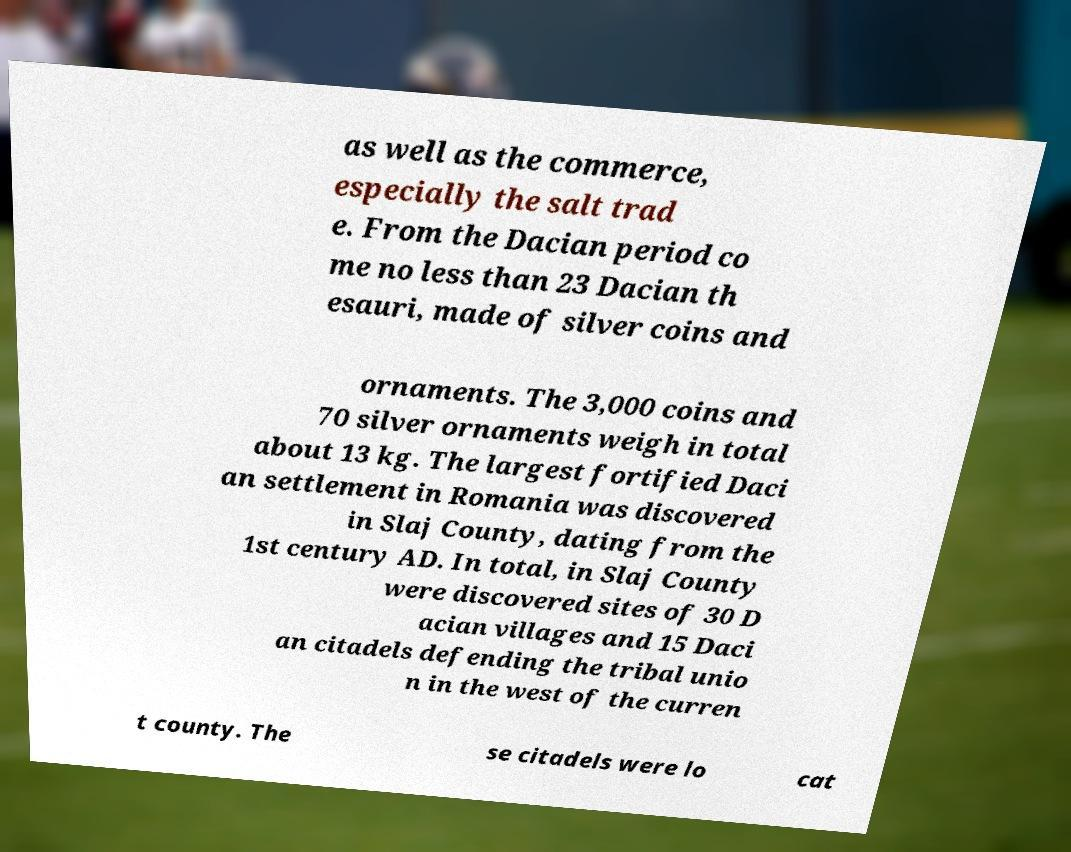I need the written content from this picture converted into text. Can you do that? as well as the commerce, especially the salt trad e. From the Dacian period co me no less than 23 Dacian th esauri, made of silver coins and ornaments. The 3,000 coins and 70 silver ornaments weigh in total about 13 kg. The largest fortified Daci an settlement in Romania was discovered in Slaj County, dating from the 1st century AD. In total, in Slaj County were discovered sites of 30 D acian villages and 15 Daci an citadels defending the tribal unio n in the west of the curren t county. The se citadels were lo cat 